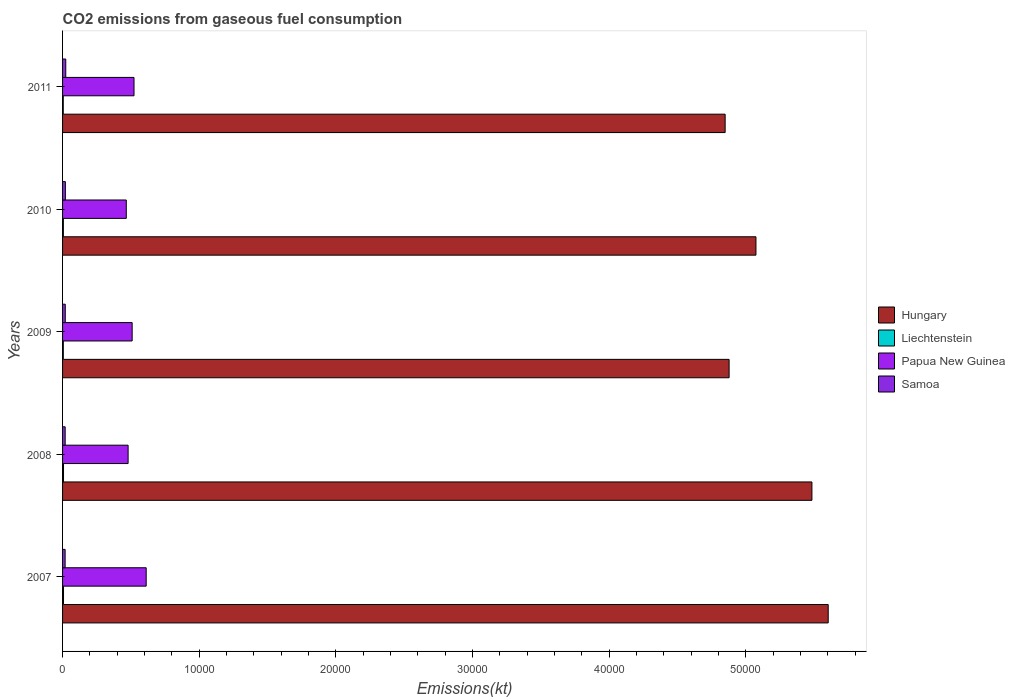Are the number of bars on each tick of the Y-axis equal?
Make the answer very short. Yes. How many bars are there on the 4th tick from the top?
Your response must be concise. 4. How many bars are there on the 1st tick from the bottom?
Your answer should be compact. 4. What is the label of the 1st group of bars from the top?
Ensure brevity in your answer.  2011. What is the amount of CO2 emitted in Papua New Guinea in 2010?
Provide a succinct answer. 4664.42. Across all years, what is the maximum amount of CO2 emitted in Papua New Guinea?
Give a very brief answer. 6120.22. Across all years, what is the minimum amount of CO2 emitted in Liechtenstein?
Keep it short and to the point. 51.34. In which year was the amount of CO2 emitted in Liechtenstein minimum?
Ensure brevity in your answer.  2011. What is the total amount of CO2 emitted in Papua New Guinea in the graph?
Provide a short and direct response. 2.59e+04. What is the difference between the amount of CO2 emitted in Samoa in 2009 and that in 2010?
Ensure brevity in your answer.  -7.33. What is the difference between the amount of CO2 emitted in Hungary in 2009 and the amount of CO2 emitted in Papua New Guinea in 2011?
Your response must be concise. 4.36e+04. What is the average amount of CO2 emitted in Liechtenstein per year?
Provide a short and direct response. 60.87. In the year 2010, what is the difference between the amount of CO2 emitted in Hungary and amount of CO2 emitted in Liechtenstein?
Your answer should be compact. 5.07e+04. In how many years, is the amount of CO2 emitted in Papua New Guinea greater than 40000 kt?
Ensure brevity in your answer.  0. What is the ratio of the amount of CO2 emitted in Hungary in 2008 to that in 2011?
Your answer should be compact. 1.13. Is the amount of CO2 emitted in Liechtenstein in 2008 less than that in 2009?
Your response must be concise. No. What is the difference between the highest and the second highest amount of CO2 emitted in Hungary?
Provide a short and direct response. 1191.78. What is the difference between the highest and the lowest amount of CO2 emitted in Liechtenstein?
Your answer should be very brief. 18.34. Is it the case that in every year, the sum of the amount of CO2 emitted in Papua New Guinea and amount of CO2 emitted in Samoa is greater than the sum of amount of CO2 emitted in Hungary and amount of CO2 emitted in Liechtenstein?
Provide a short and direct response. Yes. What does the 3rd bar from the top in 2007 represents?
Give a very brief answer. Liechtenstein. What does the 1st bar from the bottom in 2011 represents?
Make the answer very short. Hungary. How many bars are there?
Offer a very short reply. 20. Are all the bars in the graph horizontal?
Offer a terse response. Yes. What is the difference between two consecutive major ticks on the X-axis?
Provide a succinct answer. 10000. Are the values on the major ticks of X-axis written in scientific E-notation?
Keep it short and to the point. No. Does the graph contain grids?
Your response must be concise. No. How many legend labels are there?
Your answer should be very brief. 4. What is the title of the graph?
Keep it short and to the point. CO2 emissions from gaseous fuel consumption. Does "Brunei Darussalam" appear as one of the legend labels in the graph?
Your answer should be compact. No. What is the label or title of the X-axis?
Your response must be concise. Emissions(kt). What is the Emissions(kt) of Hungary in 2007?
Make the answer very short. 5.60e+04. What is the Emissions(kt) of Liechtenstein in 2007?
Make the answer very short. 69.67. What is the Emissions(kt) of Papua New Guinea in 2007?
Offer a terse response. 6120.22. What is the Emissions(kt) of Samoa in 2007?
Make the answer very short. 187.02. What is the Emissions(kt) in Hungary in 2008?
Your answer should be very brief. 5.48e+04. What is the Emissions(kt) in Liechtenstein in 2008?
Make the answer very short. 69.67. What is the Emissions(kt) in Papua New Guinea in 2008?
Provide a short and direct response. 4796.44. What is the Emissions(kt) in Samoa in 2008?
Your answer should be compact. 190.68. What is the Emissions(kt) of Hungary in 2009?
Ensure brevity in your answer.  4.88e+04. What is the Emissions(kt) of Liechtenstein in 2009?
Offer a very short reply. 55.01. What is the Emissions(kt) in Papua New Guinea in 2009?
Make the answer very short. 5093.46. What is the Emissions(kt) in Samoa in 2009?
Ensure brevity in your answer.  198.02. What is the Emissions(kt) in Hungary in 2010?
Keep it short and to the point. 5.07e+04. What is the Emissions(kt) in Liechtenstein in 2010?
Provide a short and direct response. 58.67. What is the Emissions(kt) of Papua New Guinea in 2010?
Offer a terse response. 4664.42. What is the Emissions(kt) of Samoa in 2010?
Ensure brevity in your answer.  205.35. What is the Emissions(kt) of Hungary in 2011?
Provide a succinct answer. 4.85e+04. What is the Emissions(kt) in Liechtenstein in 2011?
Your answer should be compact. 51.34. What is the Emissions(kt) in Papua New Guinea in 2011?
Give a very brief answer. 5229.14. What is the Emissions(kt) of Samoa in 2011?
Ensure brevity in your answer.  234.69. Across all years, what is the maximum Emissions(kt) of Hungary?
Your answer should be compact. 5.60e+04. Across all years, what is the maximum Emissions(kt) in Liechtenstein?
Provide a succinct answer. 69.67. Across all years, what is the maximum Emissions(kt) of Papua New Guinea?
Keep it short and to the point. 6120.22. Across all years, what is the maximum Emissions(kt) in Samoa?
Make the answer very short. 234.69. Across all years, what is the minimum Emissions(kt) in Hungary?
Offer a terse response. 4.85e+04. Across all years, what is the minimum Emissions(kt) of Liechtenstein?
Offer a very short reply. 51.34. Across all years, what is the minimum Emissions(kt) in Papua New Guinea?
Make the answer very short. 4664.42. Across all years, what is the minimum Emissions(kt) of Samoa?
Your answer should be compact. 187.02. What is the total Emissions(kt) in Hungary in the graph?
Keep it short and to the point. 2.59e+05. What is the total Emissions(kt) in Liechtenstein in the graph?
Offer a very short reply. 304.36. What is the total Emissions(kt) in Papua New Guinea in the graph?
Keep it short and to the point. 2.59e+04. What is the total Emissions(kt) in Samoa in the graph?
Keep it short and to the point. 1015.76. What is the difference between the Emissions(kt) in Hungary in 2007 and that in 2008?
Offer a very short reply. 1191.78. What is the difference between the Emissions(kt) in Papua New Guinea in 2007 and that in 2008?
Your response must be concise. 1323.79. What is the difference between the Emissions(kt) of Samoa in 2007 and that in 2008?
Offer a terse response. -3.67. What is the difference between the Emissions(kt) of Hungary in 2007 and that in 2009?
Give a very brief answer. 7253.33. What is the difference between the Emissions(kt) in Liechtenstein in 2007 and that in 2009?
Your answer should be very brief. 14.67. What is the difference between the Emissions(kt) of Papua New Guinea in 2007 and that in 2009?
Keep it short and to the point. 1026.76. What is the difference between the Emissions(kt) in Samoa in 2007 and that in 2009?
Your response must be concise. -11. What is the difference between the Emissions(kt) in Hungary in 2007 and that in 2010?
Provide a short and direct response. 5287.81. What is the difference between the Emissions(kt) of Liechtenstein in 2007 and that in 2010?
Offer a terse response. 11. What is the difference between the Emissions(kt) of Papua New Guinea in 2007 and that in 2010?
Ensure brevity in your answer.  1455.8. What is the difference between the Emissions(kt) in Samoa in 2007 and that in 2010?
Keep it short and to the point. -18.34. What is the difference between the Emissions(kt) of Hungary in 2007 and that in 2011?
Keep it short and to the point. 7543.02. What is the difference between the Emissions(kt) in Liechtenstein in 2007 and that in 2011?
Ensure brevity in your answer.  18.34. What is the difference between the Emissions(kt) of Papua New Guinea in 2007 and that in 2011?
Your response must be concise. 891.08. What is the difference between the Emissions(kt) in Samoa in 2007 and that in 2011?
Provide a succinct answer. -47.67. What is the difference between the Emissions(kt) of Hungary in 2008 and that in 2009?
Keep it short and to the point. 6061.55. What is the difference between the Emissions(kt) of Liechtenstein in 2008 and that in 2009?
Make the answer very short. 14.67. What is the difference between the Emissions(kt) of Papua New Guinea in 2008 and that in 2009?
Make the answer very short. -297.03. What is the difference between the Emissions(kt) of Samoa in 2008 and that in 2009?
Make the answer very short. -7.33. What is the difference between the Emissions(kt) in Hungary in 2008 and that in 2010?
Keep it short and to the point. 4096.04. What is the difference between the Emissions(kt) of Liechtenstein in 2008 and that in 2010?
Ensure brevity in your answer.  11. What is the difference between the Emissions(kt) in Papua New Guinea in 2008 and that in 2010?
Your answer should be very brief. 132.01. What is the difference between the Emissions(kt) in Samoa in 2008 and that in 2010?
Offer a terse response. -14.67. What is the difference between the Emissions(kt) in Hungary in 2008 and that in 2011?
Keep it short and to the point. 6351.24. What is the difference between the Emissions(kt) of Liechtenstein in 2008 and that in 2011?
Provide a short and direct response. 18.34. What is the difference between the Emissions(kt) in Papua New Guinea in 2008 and that in 2011?
Offer a terse response. -432.71. What is the difference between the Emissions(kt) of Samoa in 2008 and that in 2011?
Keep it short and to the point. -44. What is the difference between the Emissions(kt) of Hungary in 2009 and that in 2010?
Ensure brevity in your answer.  -1965.51. What is the difference between the Emissions(kt) of Liechtenstein in 2009 and that in 2010?
Make the answer very short. -3.67. What is the difference between the Emissions(kt) of Papua New Guinea in 2009 and that in 2010?
Offer a very short reply. 429.04. What is the difference between the Emissions(kt) in Samoa in 2009 and that in 2010?
Offer a terse response. -7.33. What is the difference between the Emissions(kt) in Hungary in 2009 and that in 2011?
Keep it short and to the point. 289.69. What is the difference between the Emissions(kt) of Liechtenstein in 2009 and that in 2011?
Ensure brevity in your answer.  3.67. What is the difference between the Emissions(kt) in Papua New Guinea in 2009 and that in 2011?
Offer a terse response. -135.68. What is the difference between the Emissions(kt) of Samoa in 2009 and that in 2011?
Provide a short and direct response. -36.67. What is the difference between the Emissions(kt) of Hungary in 2010 and that in 2011?
Give a very brief answer. 2255.2. What is the difference between the Emissions(kt) in Liechtenstein in 2010 and that in 2011?
Your answer should be compact. 7.33. What is the difference between the Emissions(kt) of Papua New Guinea in 2010 and that in 2011?
Your response must be concise. -564.72. What is the difference between the Emissions(kt) in Samoa in 2010 and that in 2011?
Your response must be concise. -29.34. What is the difference between the Emissions(kt) in Hungary in 2007 and the Emissions(kt) in Liechtenstein in 2008?
Your answer should be very brief. 5.60e+04. What is the difference between the Emissions(kt) in Hungary in 2007 and the Emissions(kt) in Papua New Guinea in 2008?
Your answer should be very brief. 5.12e+04. What is the difference between the Emissions(kt) of Hungary in 2007 and the Emissions(kt) of Samoa in 2008?
Make the answer very short. 5.58e+04. What is the difference between the Emissions(kt) of Liechtenstein in 2007 and the Emissions(kt) of Papua New Guinea in 2008?
Your response must be concise. -4726.76. What is the difference between the Emissions(kt) of Liechtenstein in 2007 and the Emissions(kt) of Samoa in 2008?
Provide a short and direct response. -121.01. What is the difference between the Emissions(kt) in Papua New Guinea in 2007 and the Emissions(kt) in Samoa in 2008?
Provide a short and direct response. 5929.54. What is the difference between the Emissions(kt) in Hungary in 2007 and the Emissions(kt) in Liechtenstein in 2009?
Make the answer very short. 5.60e+04. What is the difference between the Emissions(kt) of Hungary in 2007 and the Emissions(kt) of Papua New Guinea in 2009?
Ensure brevity in your answer.  5.09e+04. What is the difference between the Emissions(kt) in Hungary in 2007 and the Emissions(kt) in Samoa in 2009?
Provide a short and direct response. 5.58e+04. What is the difference between the Emissions(kt) in Liechtenstein in 2007 and the Emissions(kt) in Papua New Guinea in 2009?
Provide a succinct answer. -5023.79. What is the difference between the Emissions(kt) of Liechtenstein in 2007 and the Emissions(kt) of Samoa in 2009?
Provide a short and direct response. -128.34. What is the difference between the Emissions(kt) of Papua New Guinea in 2007 and the Emissions(kt) of Samoa in 2009?
Give a very brief answer. 5922.2. What is the difference between the Emissions(kt) of Hungary in 2007 and the Emissions(kt) of Liechtenstein in 2010?
Your response must be concise. 5.60e+04. What is the difference between the Emissions(kt) in Hungary in 2007 and the Emissions(kt) in Papua New Guinea in 2010?
Provide a short and direct response. 5.14e+04. What is the difference between the Emissions(kt) of Hungary in 2007 and the Emissions(kt) of Samoa in 2010?
Make the answer very short. 5.58e+04. What is the difference between the Emissions(kt) of Liechtenstein in 2007 and the Emissions(kt) of Papua New Guinea in 2010?
Make the answer very short. -4594.75. What is the difference between the Emissions(kt) of Liechtenstein in 2007 and the Emissions(kt) of Samoa in 2010?
Make the answer very short. -135.68. What is the difference between the Emissions(kt) in Papua New Guinea in 2007 and the Emissions(kt) in Samoa in 2010?
Ensure brevity in your answer.  5914.87. What is the difference between the Emissions(kt) of Hungary in 2007 and the Emissions(kt) of Liechtenstein in 2011?
Give a very brief answer. 5.60e+04. What is the difference between the Emissions(kt) of Hungary in 2007 and the Emissions(kt) of Papua New Guinea in 2011?
Provide a short and direct response. 5.08e+04. What is the difference between the Emissions(kt) in Hungary in 2007 and the Emissions(kt) in Samoa in 2011?
Ensure brevity in your answer.  5.58e+04. What is the difference between the Emissions(kt) in Liechtenstein in 2007 and the Emissions(kt) in Papua New Guinea in 2011?
Your response must be concise. -5159.47. What is the difference between the Emissions(kt) in Liechtenstein in 2007 and the Emissions(kt) in Samoa in 2011?
Make the answer very short. -165.01. What is the difference between the Emissions(kt) in Papua New Guinea in 2007 and the Emissions(kt) in Samoa in 2011?
Your response must be concise. 5885.53. What is the difference between the Emissions(kt) in Hungary in 2008 and the Emissions(kt) in Liechtenstein in 2009?
Offer a very short reply. 5.48e+04. What is the difference between the Emissions(kt) of Hungary in 2008 and the Emissions(kt) of Papua New Guinea in 2009?
Provide a short and direct response. 4.98e+04. What is the difference between the Emissions(kt) in Hungary in 2008 and the Emissions(kt) in Samoa in 2009?
Your answer should be very brief. 5.46e+04. What is the difference between the Emissions(kt) in Liechtenstein in 2008 and the Emissions(kt) in Papua New Guinea in 2009?
Ensure brevity in your answer.  -5023.79. What is the difference between the Emissions(kt) in Liechtenstein in 2008 and the Emissions(kt) in Samoa in 2009?
Provide a short and direct response. -128.34. What is the difference between the Emissions(kt) in Papua New Guinea in 2008 and the Emissions(kt) in Samoa in 2009?
Give a very brief answer. 4598.42. What is the difference between the Emissions(kt) in Hungary in 2008 and the Emissions(kt) in Liechtenstein in 2010?
Give a very brief answer. 5.48e+04. What is the difference between the Emissions(kt) of Hungary in 2008 and the Emissions(kt) of Papua New Guinea in 2010?
Offer a very short reply. 5.02e+04. What is the difference between the Emissions(kt) of Hungary in 2008 and the Emissions(kt) of Samoa in 2010?
Offer a very short reply. 5.46e+04. What is the difference between the Emissions(kt) of Liechtenstein in 2008 and the Emissions(kt) of Papua New Guinea in 2010?
Your answer should be compact. -4594.75. What is the difference between the Emissions(kt) of Liechtenstein in 2008 and the Emissions(kt) of Samoa in 2010?
Keep it short and to the point. -135.68. What is the difference between the Emissions(kt) of Papua New Guinea in 2008 and the Emissions(kt) of Samoa in 2010?
Offer a very short reply. 4591.08. What is the difference between the Emissions(kt) of Hungary in 2008 and the Emissions(kt) of Liechtenstein in 2011?
Keep it short and to the point. 5.48e+04. What is the difference between the Emissions(kt) in Hungary in 2008 and the Emissions(kt) in Papua New Guinea in 2011?
Provide a short and direct response. 4.96e+04. What is the difference between the Emissions(kt) of Hungary in 2008 and the Emissions(kt) of Samoa in 2011?
Make the answer very short. 5.46e+04. What is the difference between the Emissions(kt) in Liechtenstein in 2008 and the Emissions(kt) in Papua New Guinea in 2011?
Provide a short and direct response. -5159.47. What is the difference between the Emissions(kt) in Liechtenstein in 2008 and the Emissions(kt) in Samoa in 2011?
Provide a short and direct response. -165.01. What is the difference between the Emissions(kt) of Papua New Guinea in 2008 and the Emissions(kt) of Samoa in 2011?
Keep it short and to the point. 4561.75. What is the difference between the Emissions(kt) in Hungary in 2009 and the Emissions(kt) in Liechtenstein in 2010?
Your answer should be compact. 4.87e+04. What is the difference between the Emissions(kt) of Hungary in 2009 and the Emissions(kt) of Papua New Guinea in 2010?
Your response must be concise. 4.41e+04. What is the difference between the Emissions(kt) of Hungary in 2009 and the Emissions(kt) of Samoa in 2010?
Your response must be concise. 4.86e+04. What is the difference between the Emissions(kt) in Liechtenstein in 2009 and the Emissions(kt) in Papua New Guinea in 2010?
Ensure brevity in your answer.  -4609.42. What is the difference between the Emissions(kt) of Liechtenstein in 2009 and the Emissions(kt) of Samoa in 2010?
Offer a very short reply. -150.35. What is the difference between the Emissions(kt) of Papua New Guinea in 2009 and the Emissions(kt) of Samoa in 2010?
Provide a short and direct response. 4888.11. What is the difference between the Emissions(kt) in Hungary in 2009 and the Emissions(kt) in Liechtenstein in 2011?
Make the answer very short. 4.87e+04. What is the difference between the Emissions(kt) of Hungary in 2009 and the Emissions(kt) of Papua New Guinea in 2011?
Your response must be concise. 4.36e+04. What is the difference between the Emissions(kt) of Hungary in 2009 and the Emissions(kt) of Samoa in 2011?
Ensure brevity in your answer.  4.85e+04. What is the difference between the Emissions(kt) in Liechtenstein in 2009 and the Emissions(kt) in Papua New Guinea in 2011?
Provide a succinct answer. -5174.14. What is the difference between the Emissions(kt) of Liechtenstein in 2009 and the Emissions(kt) of Samoa in 2011?
Give a very brief answer. -179.68. What is the difference between the Emissions(kt) of Papua New Guinea in 2009 and the Emissions(kt) of Samoa in 2011?
Your answer should be compact. 4858.77. What is the difference between the Emissions(kt) in Hungary in 2010 and the Emissions(kt) in Liechtenstein in 2011?
Your response must be concise. 5.07e+04. What is the difference between the Emissions(kt) of Hungary in 2010 and the Emissions(kt) of Papua New Guinea in 2011?
Provide a succinct answer. 4.55e+04. What is the difference between the Emissions(kt) in Hungary in 2010 and the Emissions(kt) in Samoa in 2011?
Keep it short and to the point. 5.05e+04. What is the difference between the Emissions(kt) in Liechtenstein in 2010 and the Emissions(kt) in Papua New Guinea in 2011?
Your response must be concise. -5170.47. What is the difference between the Emissions(kt) in Liechtenstein in 2010 and the Emissions(kt) in Samoa in 2011?
Your answer should be very brief. -176.02. What is the difference between the Emissions(kt) in Papua New Guinea in 2010 and the Emissions(kt) in Samoa in 2011?
Offer a very short reply. 4429.74. What is the average Emissions(kt) of Hungary per year?
Offer a very short reply. 5.18e+04. What is the average Emissions(kt) in Liechtenstein per year?
Provide a short and direct response. 60.87. What is the average Emissions(kt) of Papua New Guinea per year?
Keep it short and to the point. 5180.74. What is the average Emissions(kt) in Samoa per year?
Offer a terse response. 203.15. In the year 2007, what is the difference between the Emissions(kt) in Hungary and Emissions(kt) in Liechtenstein?
Your answer should be compact. 5.60e+04. In the year 2007, what is the difference between the Emissions(kt) of Hungary and Emissions(kt) of Papua New Guinea?
Provide a succinct answer. 4.99e+04. In the year 2007, what is the difference between the Emissions(kt) in Hungary and Emissions(kt) in Samoa?
Your answer should be very brief. 5.58e+04. In the year 2007, what is the difference between the Emissions(kt) in Liechtenstein and Emissions(kt) in Papua New Guinea?
Provide a succinct answer. -6050.55. In the year 2007, what is the difference between the Emissions(kt) of Liechtenstein and Emissions(kt) of Samoa?
Your answer should be very brief. -117.34. In the year 2007, what is the difference between the Emissions(kt) of Papua New Guinea and Emissions(kt) of Samoa?
Offer a very short reply. 5933.21. In the year 2008, what is the difference between the Emissions(kt) in Hungary and Emissions(kt) in Liechtenstein?
Offer a very short reply. 5.48e+04. In the year 2008, what is the difference between the Emissions(kt) in Hungary and Emissions(kt) in Papua New Guinea?
Give a very brief answer. 5.00e+04. In the year 2008, what is the difference between the Emissions(kt) of Hungary and Emissions(kt) of Samoa?
Offer a very short reply. 5.47e+04. In the year 2008, what is the difference between the Emissions(kt) in Liechtenstein and Emissions(kt) in Papua New Guinea?
Provide a succinct answer. -4726.76. In the year 2008, what is the difference between the Emissions(kt) in Liechtenstein and Emissions(kt) in Samoa?
Make the answer very short. -121.01. In the year 2008, what is the difference between the Emissions(kt) of Papua New Guinea and Emissions(kt) of Samoa?
Provide a short and direct response. 4605.75. In the year 2009, what is the difference between the Emissions(kt) in Hungary and Emissions(kt) in Liechtenstein?
Ensure brevity in your answer.  4.87e+04. In the year 2009, what is the difference between the Emissions(kt) of Hungary and Emissions(kt) of Papua New Guinea?
Ensure brevity in your answer.  4.37e+04. In the year 2009, what is the difference between the Emissions(kt) in Hungary and Emissions(kt) in Samoa?
Make the answer very short. 4.86e+04. In the year 2009, what is the difference between the Emissions(kt) of Liechtenstein and Emissions(kt) of Papua New Guinea?
Offer a very short reply. -5038.46. In the year 2009, what is the difference between the Emissions(kt) of Liechtenstein and Emissions(kt) of Samoa?
Keep it short and to the point. -143.01. In the year 2009, what is the difference between the Emissions(kt) in Papua New Guinea and Emissions(kt) in Samoa?
Provide a succinct answer. 4895.44. In the year 2010, what is the difference between the Emissions(kt) of Hungary and Emissions(kt) of Liechtenstein?
Provide a short and direct response. 5.07e+04. In the year 2010, what is the difference between the Emissions(kt) of Hungary and Emissions(kt) of Papua New Guinea?
Provide a short and direct response. 4.61e+04. In the year 2010, what is the difference between the Emissions(kt) of Hungary and Emissions(kt) of Samoa?
Provide a short and direct response. 5.05e+04. In the year 2010, what is the difference between the Emissions(kt) in Liechtenstein and Emissions(kt) in Papua New Guinea?
Give a very brief answer. -4605.75. In the year 2010, what is the difference between the Emissions(kt) in Liechtenstein and Emissions(kt) in Samoa?
Your response must be concise. -146.68. In the year 2010, what is the difference between the Emissions(kt) in Papua New Guinea and Emissions(kt) in Samoa?
Your answer should be very brief. 4459.07. In the year 2011, what is the difference between the Emissions(kt) in Hungary and Emissions(kt) in Liechtenstein?
Give a very brief answer. 4.84e+04. In the year 2011, what is the difference between the Emissions(kt) of Hungary and Emissions(kt) of Papua New Guinea?
Give a very brief answer. 4.33e+04. In the year 2011, what is the difference between the Emissions(kt) in Hungary and Emissions(kt) in Samoa?
Your answer should be compact. 4.83e+04. In the year 2011, what is the difference between the Emissions(kt) in Liechtenstein and Emissions(kt) in Papua New Guinea?
Provide a succinct answer. -5177.8. In the year 2011, what is the difference between the Emissions(kt) of Liechtenstein and Emissions(kt) of Samoa?
Provide a succinct answer. -183.35. In the year 2011, what is the difference between the Emissions(kt) of Papua New Guinea and Emissions(kt) of Samoa?
Make the answer very short. 4994.45. What is the ratio of the Emissions(kt) of Hungary in 2007 to that in 2008?
Provide a short and direct response. 1.02. What is the ratio of the Emissions(kt) of Liechtenstein in 2007 to that in 2008?
Offer a terse response. 1. What is the ratio of the Emissions(kt) in Papua New Guinea in 2007 to that in 2008?
Provide a succinct answer. 1.28. What is the ratio of the Emissions(kt) in Samoa in 2007 to that in 2008?
Provide a succinct answer. 0.98. What is the ratio of the Emissions(kt) of Hungary in 2007 to that in 2009?
Offer a terse response. 1.15. What is the ratio of the Emissions(kt) of Liechtenstein in 2007 to that in 2009?
Your response must be concise. 1.27. What is the ratio of the Emissions(kt) in Papua New Guinea in 2007 to that in 2009?
Your answer should be very brief. 1.2. What is the ratio of the Emissions(kt) of Samoa in 2007 to that in 2009?
Keep it short and to the point. 0.94. What is the ratio of the Emissions(kt) of Hungary in 2007 to that in 2010?
Ensure brevity in your answer.  1.1. What is the ratio of the Emissions(kt) in Liechtenstein in 2007 to that in 2010?
Make the answer very short. 1.19. What is the ratio of the Emissions(kt) in Papua New Guinea in 2007 to that in 2010?
Give a very brief answer. 1.31. What is the ratio of the Emissions(kt) in Samoa in 2007 to that in 2010?
Your answer should be very brief. 0.91. What is the ratio of the Emissions(kt) in Hungary in 2007 to that in 2011?
Provide a succinct answer. 1.16. What is the ratio of the Emissions(kt) in Liechtenstein in 2007 to that in 2011?
Provide a short and direct response. 1.36. What is the ratio of the Emissions(kt) of Papua New Guinea in 2007 to that in 2011?
Keep it short and to the point. 1.17. What is the ratio of the Emissions(kt) in Samoa in 2007 to that in 2011?
Make the answer very short. 0.8. What is the ratio of the Emissions(kt) of Hungary in 2008 to that in 2009?
Keep it short and to the point. 1.12. What is the ratio of the Emissions(kt) of Liechtenstein in 2008 to that in 2009?
Your response must be concise. 1.27. What is the ratio of the Emissions(kt) in Papua New Guinea in 2008 to that in 2009?
Ensure brevity in your answer.  0.94. What is the ratio of the Emissions(kt) of Samoa in 2008 to that in 2009?
Your response must be concise. 0.96. What is the ratio of the Emissions(kt) in Hungary in 2008 to that in 2010?
Provide a short and direct response. 1.08. What is the ratio of the Emissions(kt) in Liechtenstein in 2008 to that in 2010?
Your response must be concise. 1.19. What is the ratio of the Emissions(kt) in Papua New Guinea in 2008 to that in 2010?
Your response must be concise. 1.03. What is the ratio of the Emissions(kt) of Samoa in 2008 to that in 2010?
Your response must be concise. 0.93. What is the ratio of the Emissions(kt) in Hungary in 2008 to that in 2011?
Offer a very short reply. 1.13. What is the ratio of the Emissions(kt) of Liechtenstein in 2008 to that in 2011?
Provide a short and direct response. 1.36. What is the ratio of the Emissions(kt) of Papua New Guinea in 2008 to that in 2011?
Your response must be concise. 0.92. What is the ratio of the Emissions(kt) in Samoa in 2008 to that in 2011?
Provide a succinct answer. 0.81. What is the ratio of the Emissions(kt) of Hungary in 2009 to that in 2010?
Keep it short and to the point. 0.96. What is the ratio of the Emissions(kt) of Liechtenstein in 2009 to that in 2010?
Provide a succinct answer. 0.94. What is the ratio of the Emissions(kt) in Papua New Guinea in 2009 to that in 2010?
Provide a succinct answer. 1.09. What is the ratio of the Emissions(kt) of Samoa in 2009 to that in 2010?
Give a very brief answer. 0.96. What is the ratio of the Emissions(kt) of Hungary in 2009 to that in 2011?
Your response must be concise. 1.01. What is the ratio of the Emissions(kt) in Liechtenstein in 2009 to that in 2011?
Give a very brief answer. 1.07. What is the ratio of the Emissions(kt) in Papua New Guinea in 2009 to that in 2011?
Give a very brief answer. 0.97. What is the ratio of the Emissions(kt) of Samoa in 2009 to that in 2011?
Give a very brief answer. 0.84. What is the ratio of the Emissions(kt) of Hungary in 2010 to that in 2011?
Ensure brevity in your answer.  1.05. What is the ratio of the Emissions(kt) in Liechtenstein in 2010 to that in 2011?
Make the answer very short. 1.14. What is the ratio of the Emissions(kt) in Papua New Guinea in 2010 to that in 2011?
Your answer should be compact. 0.89. What is the difference between the highest and the second highest Emissions(kt) in Hungary?
Offer a very short reply. 1191.78. What is the difference between the highest and the second highest Emissions(kt) of Papua New Guinea?
Ensure brevity in your answer.  891.08. What is the difference between the highest and the second highest Emissions(kt) in Samoa?
Give a very brief answer. 29.34. What is the difference between the highest and the lowest Emissions(kt) of Hungary?
Ensure brevity in your answer.  7543.02. What is the difference between the highest and the lowest Emissions(kt) of Liechtenstein?
Provide a short and direct response. 18.34. What is the difference between the highest and the lowest Emissions(kt) of Papua New Guinea?
Ensure brevity in your answer.  1455.8. What is the difference between the highest and the lowest Emissions(kt) of Samoa?
Your answer should be compact. 47.67. 